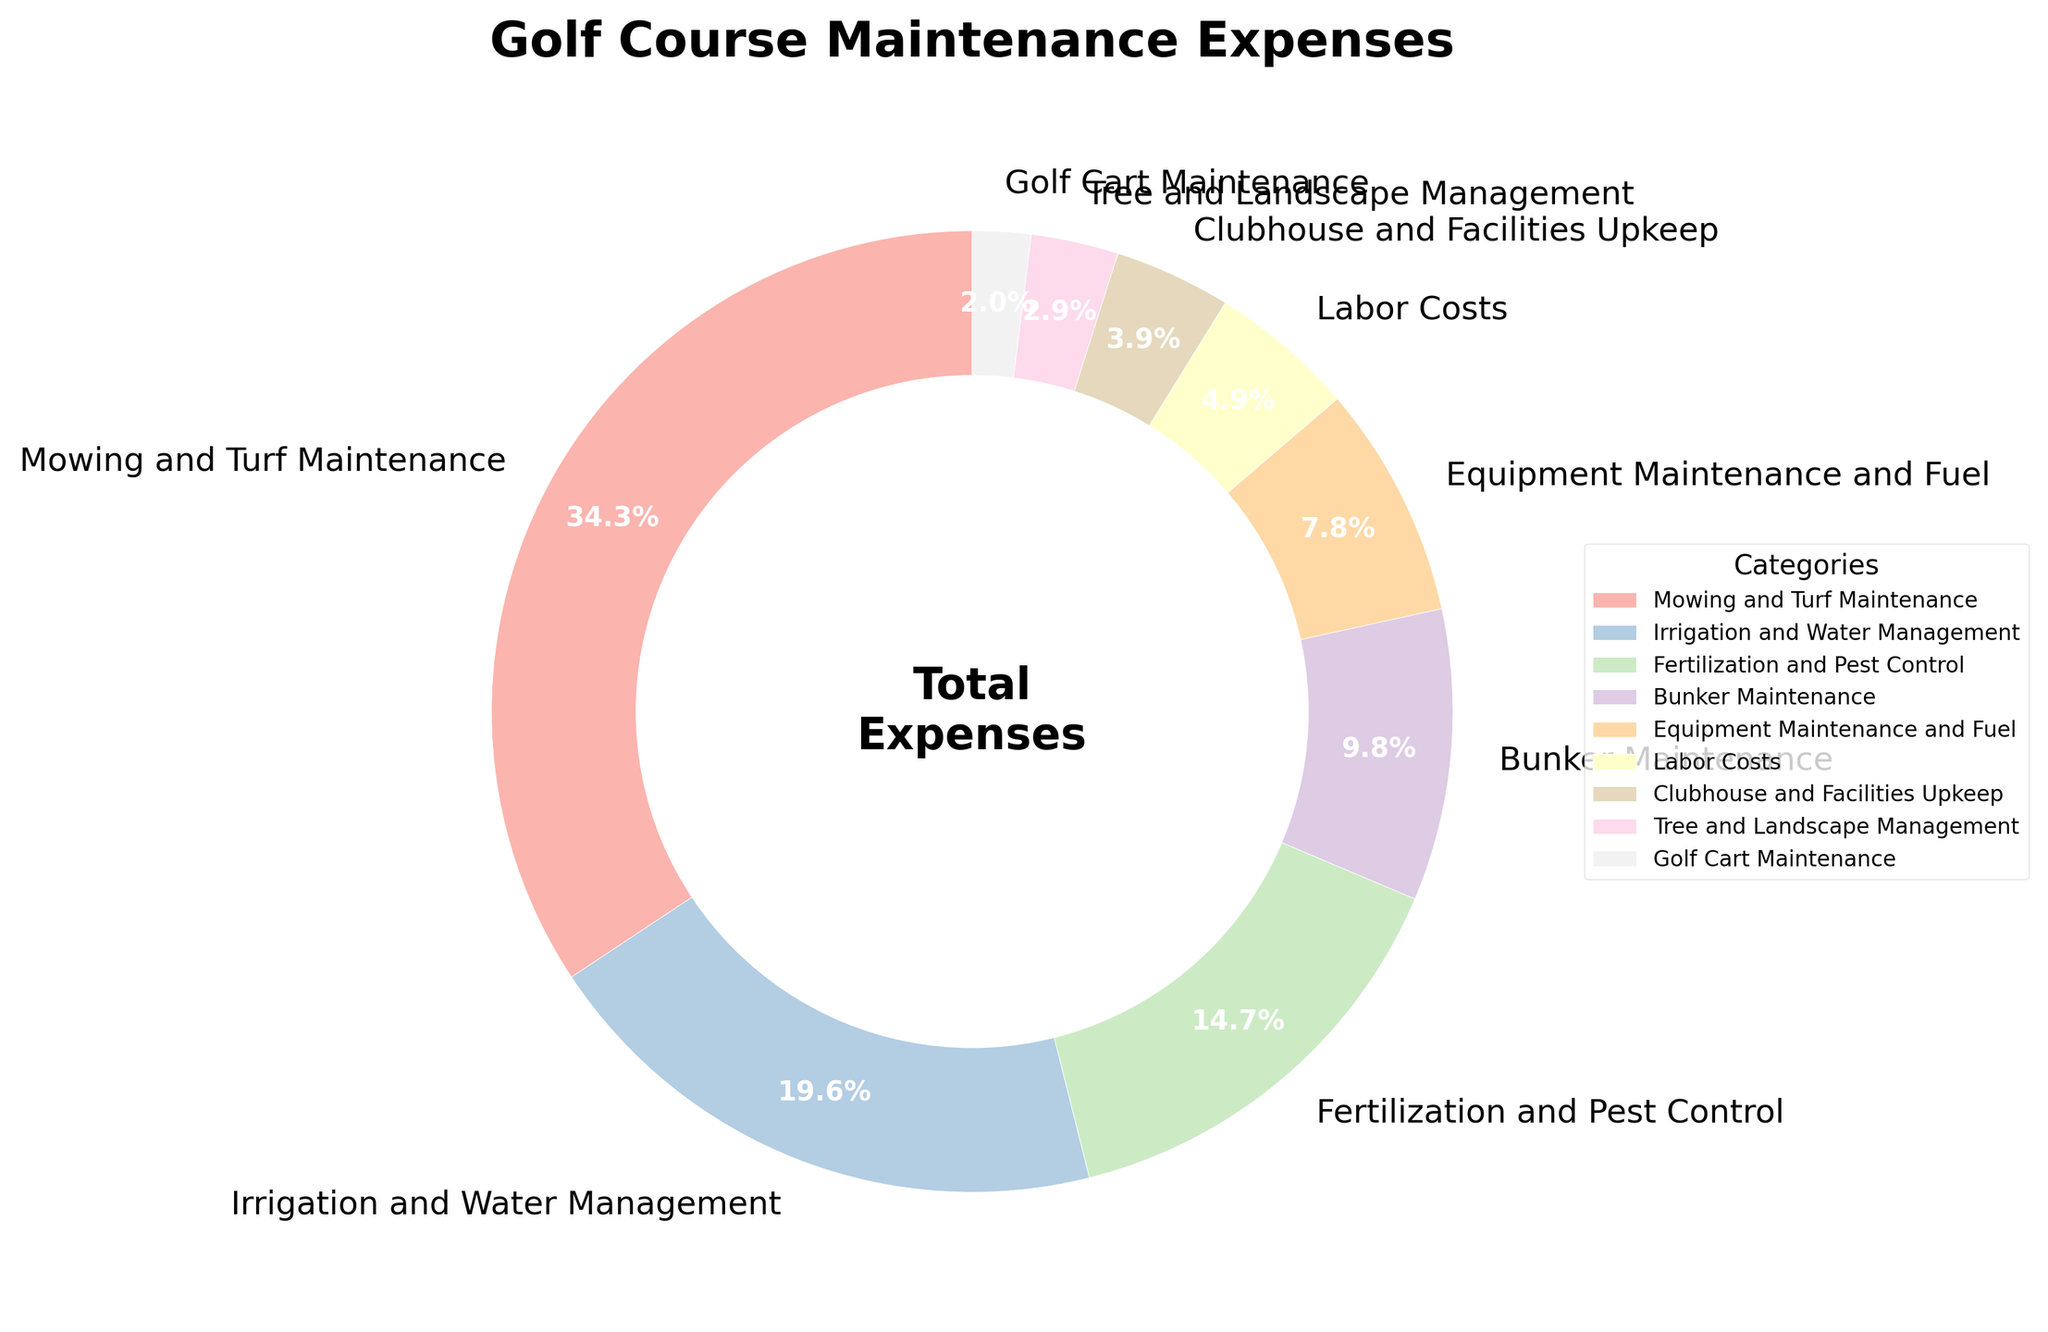What category has the highest allocation of expenses? The largest portion in the pie chart takes up 35% and is labeled "Mowing and Turf Maintenance." Therefore, this category has the highest allocation of expenses.
Answer: Mowing and Turf Maintenance Which categories together make up more than half of the total expenses? To determine which categories together make up more than 50% of the total expenses, we start with the largest percentages and sum them until the total exceeds 50%. "Mowing and Turf Maintenance" is 35%, and "Irrigation and Water Management" is 20%, which together make 55%.
Answer: Mowing and Turf Maintenance, Irrigation and Water Management What is the total percentage allocated to equipment-related expenses? Equipment-related expenses include "Equipment Maintenance and Fuel" at 8% and "Golf Cart Maintenance" at 2%. Adding these together gives 8% + 2%.
Answer: 10% Which category has a smaller allocation than "Bunker Maintenance" and by how much? "Bunker Maintenance" is allocated 10%. The only categories with smaller allocations are "Labor Costs" at 5%, "Clubhouse and Facilities Upkeep" at 4%, "Tree and Landscape Management" at 3%, and "Golf Cart Maintenance" at 2%. Each allocation difference is 10% - 5% = 5%, 10% - 4% = 6%, 10% - 3% = 7%, and 10% - 2% = 8%.
Answer: Labor Costs by 5%, Clubhouse and Facilities Upkeep by 6%, Tree and Landscape Management by 7%, Golf Cart Maintenance by 8% What is the combined percentage for "Fertilization and Pest Control" and "Bunker Maintenance"? The sum of "Fertilization and Pest Control" at 15% and "Bunker Maintenance" at 10% is calculated by adding 15% + 10%.
Answer: 25% Which expense category has the smallest allocation, and what is that percentage? The smallest segment of the pie chart represents 2% and is labeled "Golf Cart Maintenance." Thus, this category has the smallest allocation.
Answer: Golf Cart Maintenance What is the difference in percentage points between "Irrigation and Water Management" and "Clubhouse and Facilities Upkeep"? "Irrigation and Water Management" is 20% and "Clubhouse and Facilities Upkeep" is 4%, so the difference is 20% - 4%.
Answer: 16% How does the allocation for labor costs compare to tree and landscape management? "Labor Costs" are allocated 5%, while "Tree and Landscape Management" is allocated 3%. Comparing these, labor costs are 2% higher than tree and landscape management.
Answer: Labor Costs are 2% higher What categories are depicted in shades of green? To answer this question, observe the pie chart and identify slices in shades of green. Verify their corresponding labels. Since this question pertains to color and visibility in the plot, and without the actual chart image, we generalize by considering what typically might be colored thus based on common conventions if green shades are indeed visible. This might need specific visual prompts in actual checking.
Answer: (Visual Question: Requires Visual Observation) 